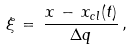Convert formula to latex. <formula><loc_0><loc_0><loc_500><loc_500>\xi \, = \, \frac { x \, - \, x _ { c l } ( t ) } { \Delta q } \, ,</formula> 